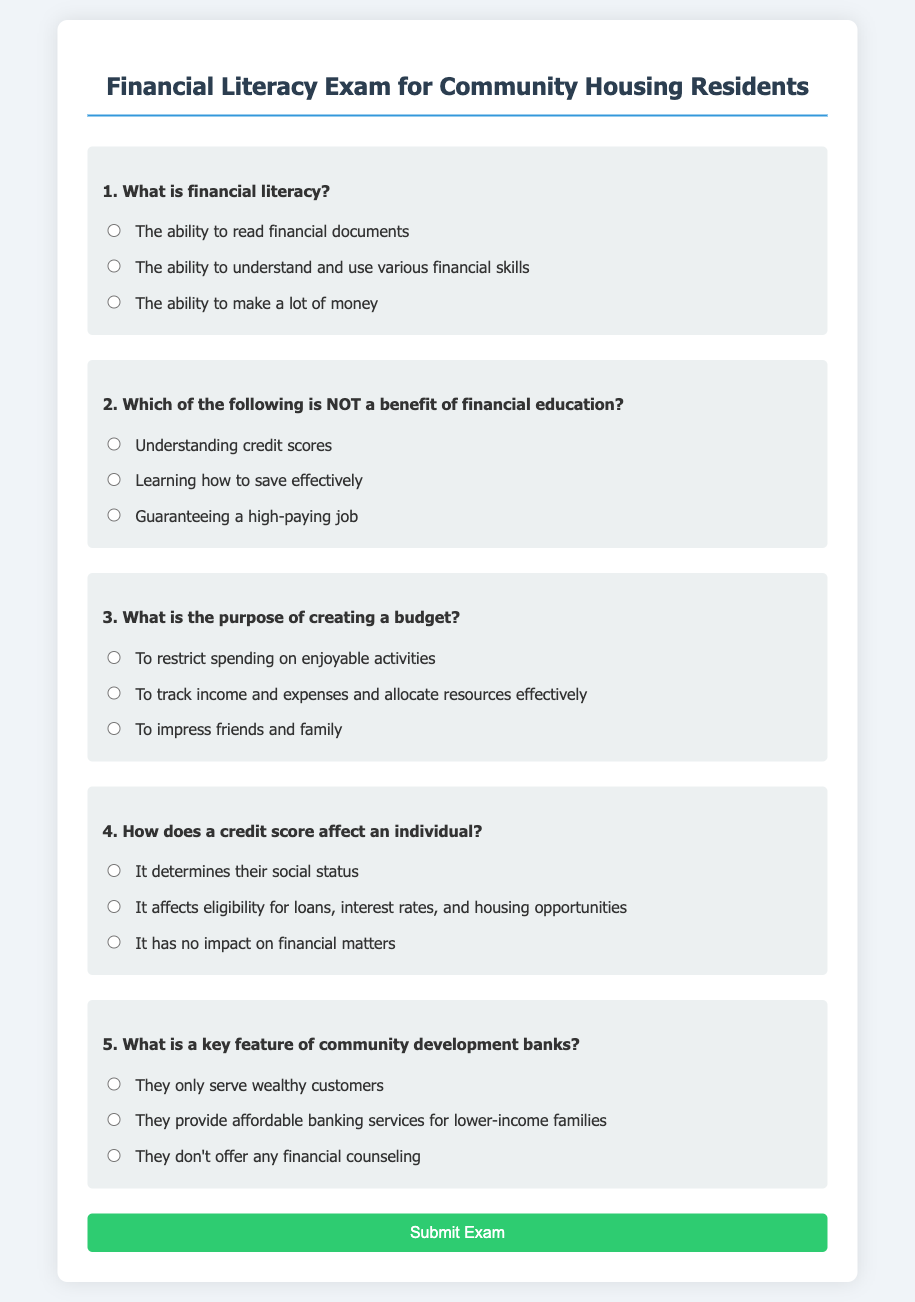What is the title of the document? The title of the document is prominently displayed at the top of the webpage.
Answer: Financial Literacy Exam for Community Housing Residents How many questions are in the exam? The document includes a total of five questions related to financial literacy.
Answer: 5 What is the purpose of creating a budget? The question focuses on the rationale behind budgeting as mentioned in the document.
Answer: To track income and expenses and allocate resources effectively Which option states a benefit of financial education? This refers to the available choices under the second question in the document.
Answer: Understanding credit scores What is a key feature of community development banks? This asks about a specific characteristic of community development banks outlined in the exam.
Answer: They provide affordable banking services for lower-income families How does a credit score affect an individual? This question relates to the impact of credit scores, as stated in one of the questions.
Answer: It affects eligibility for loans, interest rates, and housing opportunities 